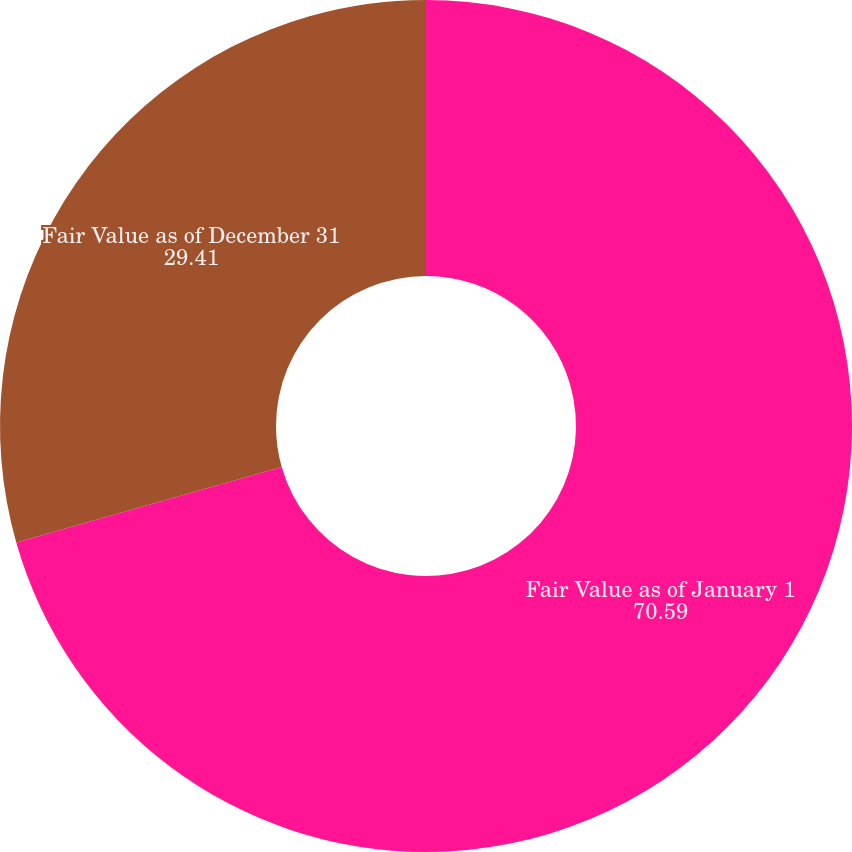Convert chart. <chart><loc_0><loc_0><loc_500><loc_500><pie_chart><fcel>Fair Value as of January 1<fcel>Fair Value as of December 31<nl><fcel>70.59%<fcel>29.41%<nl></chart> 